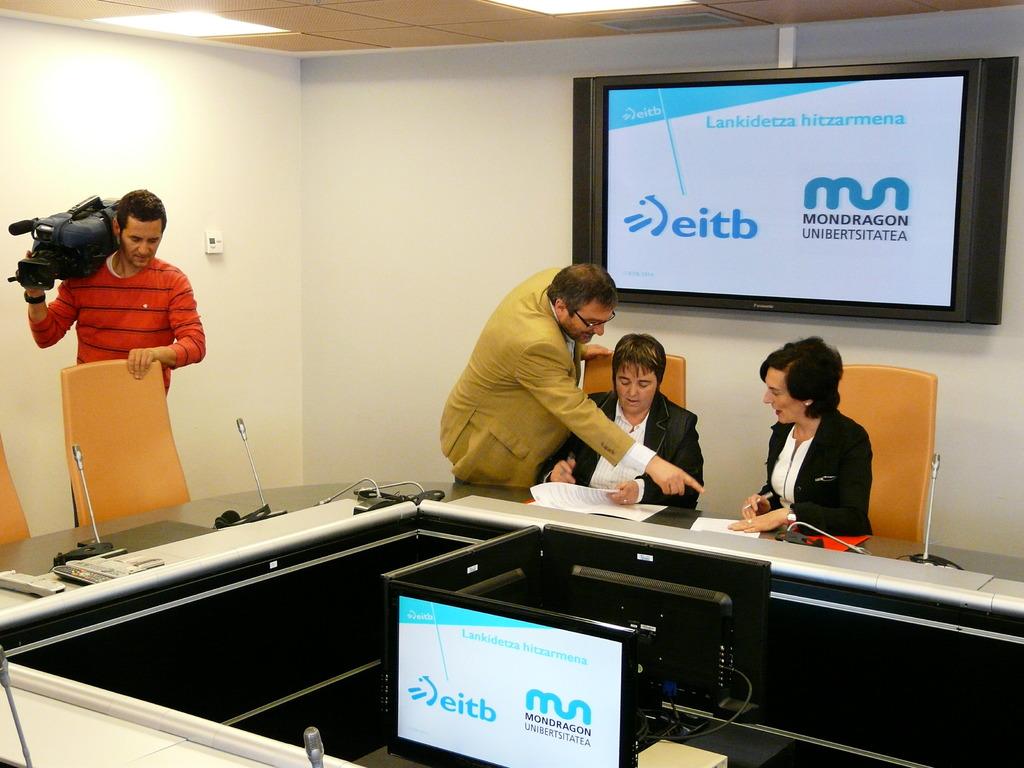What does the monitor say?
Offer a terse response. Lankidetza hitzarmena. In office meeting is going?
Provide a succinct answer. Yes. 